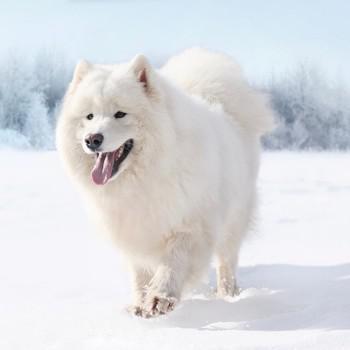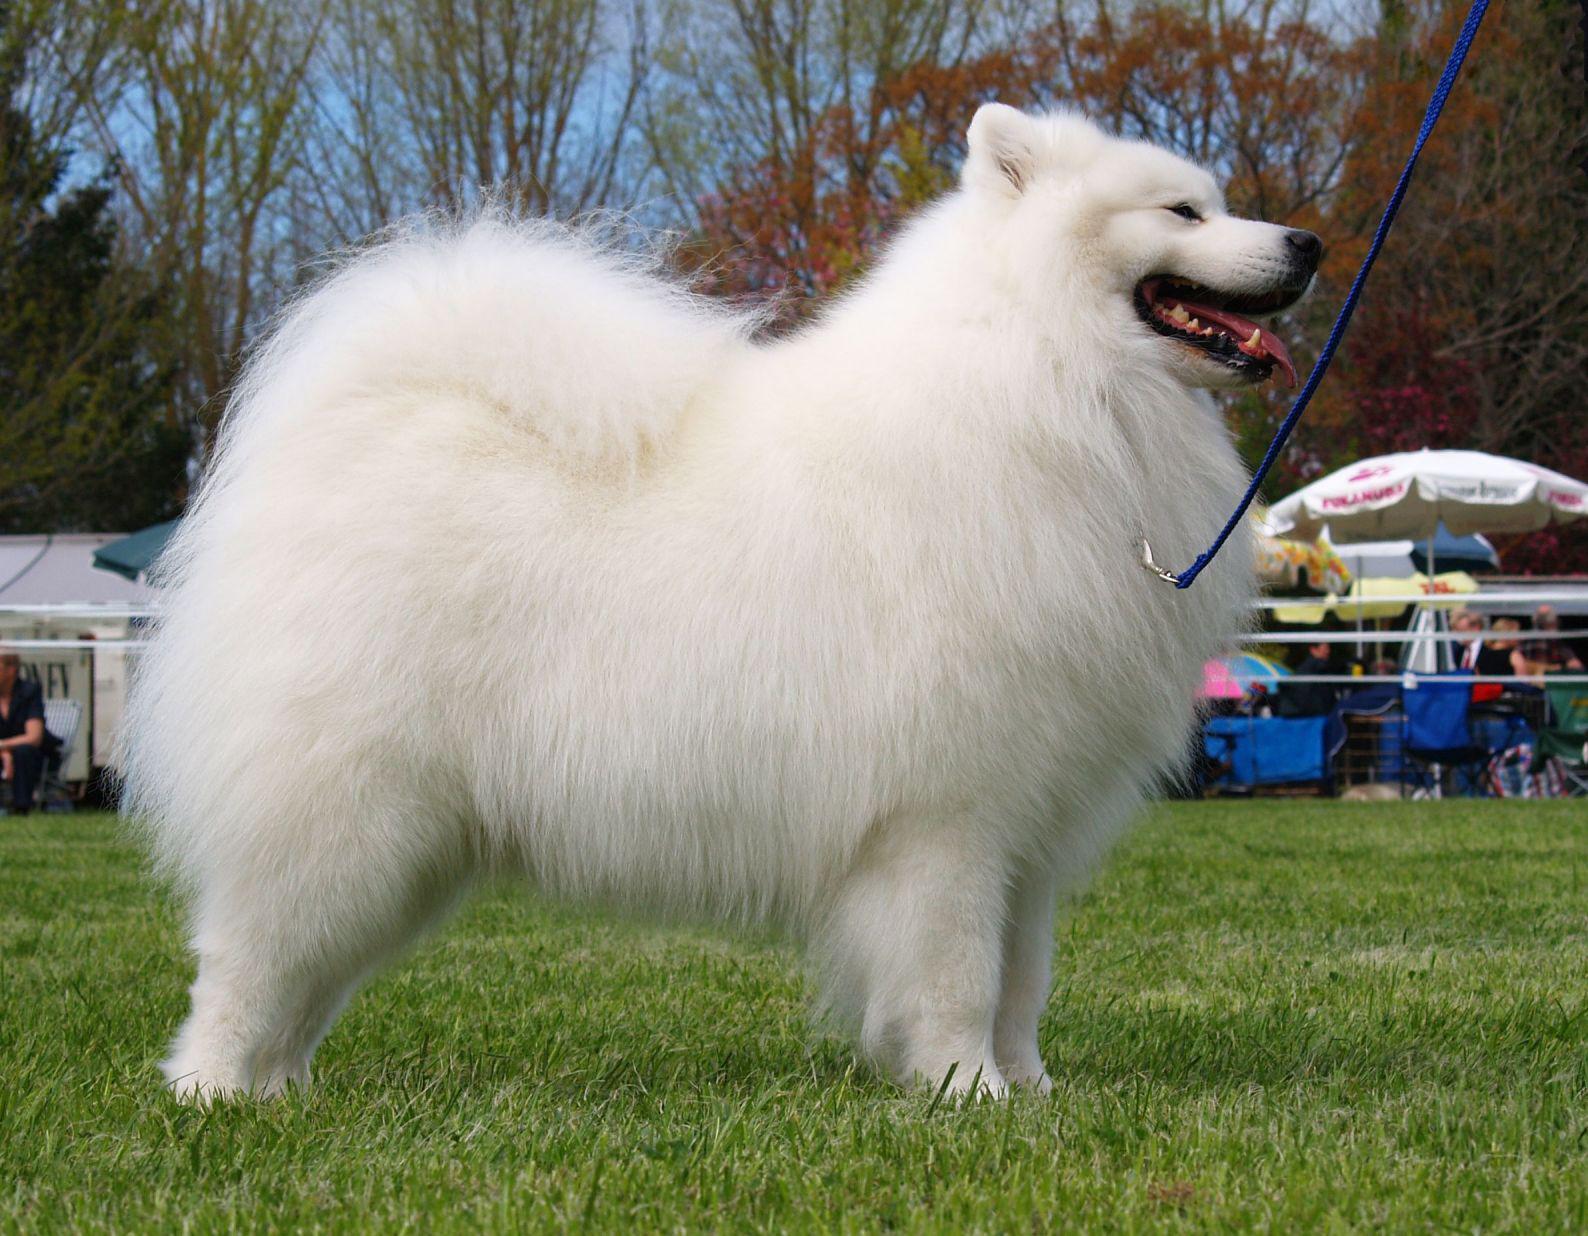The first image is the image on the left, the second image is the image on the right. Assess this claim about the two images: "in the left pic the dog is in a form of grass". Correct or not? Answer yes or no. No. The first image is the image on the left, the second image is the image on the right. Considering the images on both sides, is "Both white dogs have their tongues hanging out of their mouths." valid? Answer yes or no. Yes. 